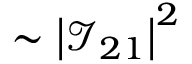Convert formula to latex. <formula><loc_0><loc_0><loc_500><loc_500>\sim \left | \mathcal { I } _ { 2 1 } \right | ^ { 2 }</formula> 